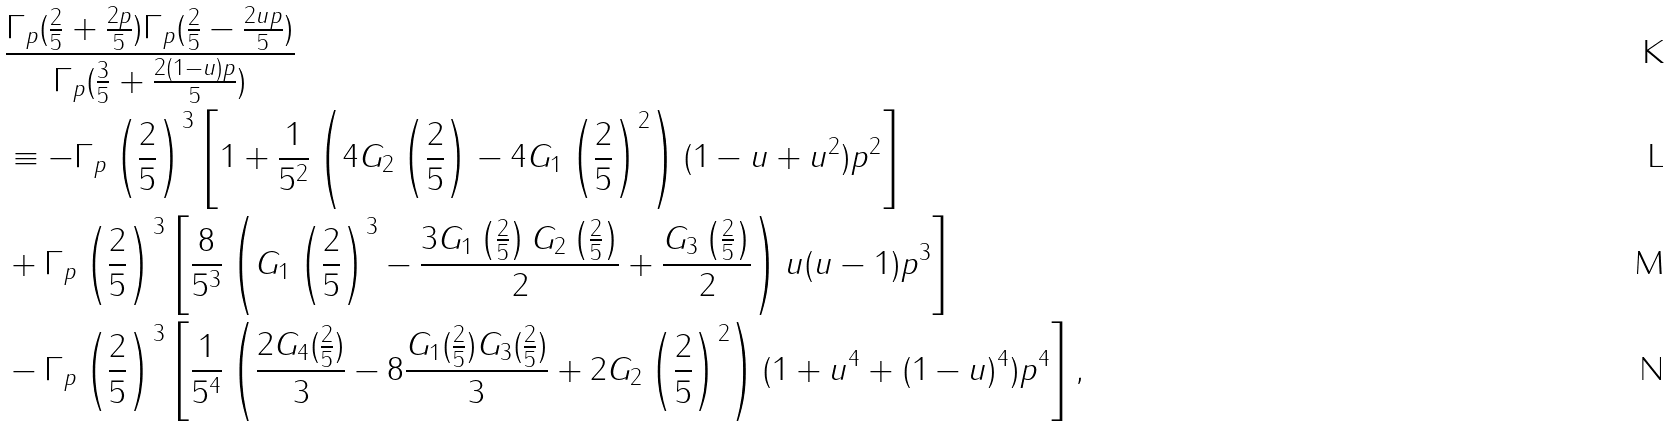Convert formula to latex. <formula><loc_0><loc_0><loc_500><loc_500>& \frac { \Gamma _ { p } ( \frac { 2 } { 5 } + \frac { 2 p } { 5 } ) \Gamma _ { p } ( \frac { 2 } { 5 } - \frac { 2 u p } { 5 } ) } { \Gamma _ { p } ( \frac { 3 } { 5 } + \frac { 2 ( 1 - u ) p } { 5 } ) } \\ & \equiv - \Gamma _ { p } \left ( \frac { 2 } { 5 } \right ) ^ { 3 } \left [ 1 + \frac { 1 } { 5 ^ { 2 } } \left ( 4 G _ { 2 } \left ( \frac { 2 } { 5 } \right ) - 4 G _ { 1 } \left ( \frac { 2 } { 5 } \right ) ^ { 2 } \right ) ( 1 - u + u ^ { 2 } ) p ^ { 2 } \right ] \\ & + \Gamma _ { p } \left ( \frac { 2 } { 5 } \right ) ^ { 3 } \left [ \frac { 8 } { 5 ^ { 3 } } \left ( G _ { 1 } \left ( \frac { 2 } { 5 } \right ) ^ { 3 } - \frac { 3 G _ { 1 } \left ( \frac { 2 } { 5 } \right ) G _ { 2 } \left ( \frac { 2 } { 5 } \right ) } { 2 } + \frac { G _ { 3 } \left ( \frac { 2 } { 5 } \right ) } { 2 } \right ) u ( u - 1 ) p ^ { 3 } \right ] \\ & - \Gamma _ { p } \left ( \frac { 2 } { 5 } \right ) ^ { 3 } \left [ \frac { 1 } { 5 ^ { 4 } } \left ( \frac { 2 G _ { 4 } ( \frac { 2 } { 5 } ) } { 3 } - 8 \frac { G _ { 1 } ( \frac { 2 } { 5 } ) G _ { 3 } ( \frac { 2 } { 5 } ) } { 3 } + 2 G _ { 2 } \left ( \frac { 2 } { 5 } \right ) ^ { 2 } \right ) ( 1 + u ^ { 4 } + ( 1 - u ) ^ { 4 } ) p ^ { 4 } \right ] ,</formula> 